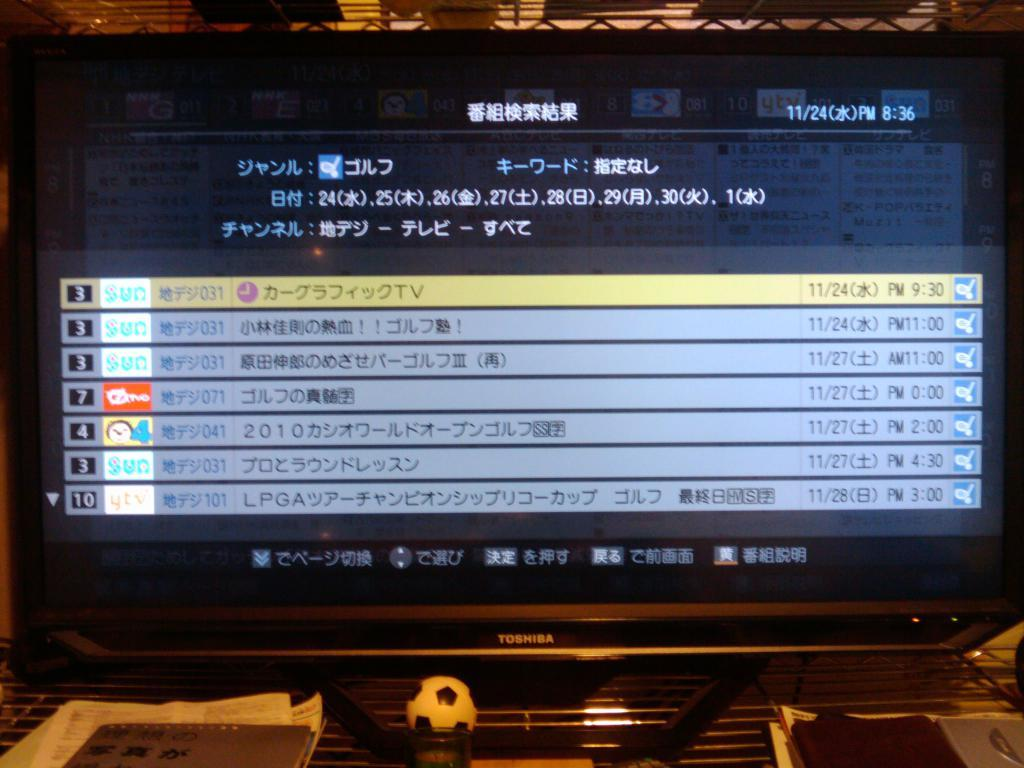Provide a one-sentence caption for the provided image. The number 3 and 7 can be seen on the left side of a computer screen. 